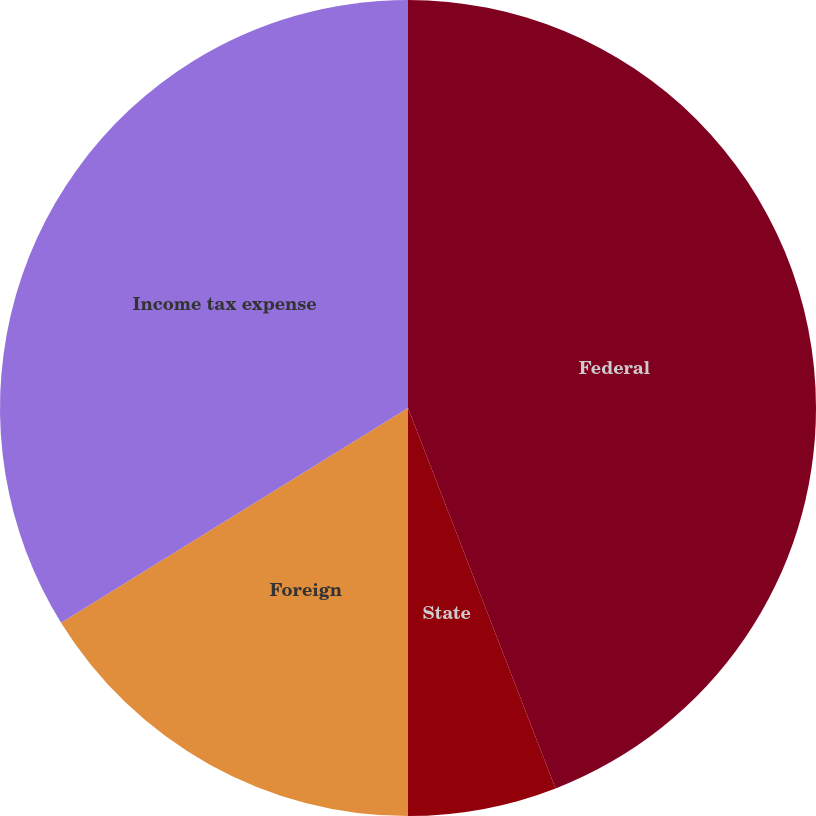<chart> <loc_0><loc_0><loc_500><loc_500><pie_chart><fcel>Federal<fcel>State<fcel>Foreign<fcel>Income tax expense<nl><fcel>44.11%<fcel>5.89%<fcel>16.18%<fcel>33.82%<nl></chart> 